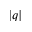Convert formula to latex. <formula><loc_0><loc_0><loc_500><loc_500>\left | q \right |</formula> 